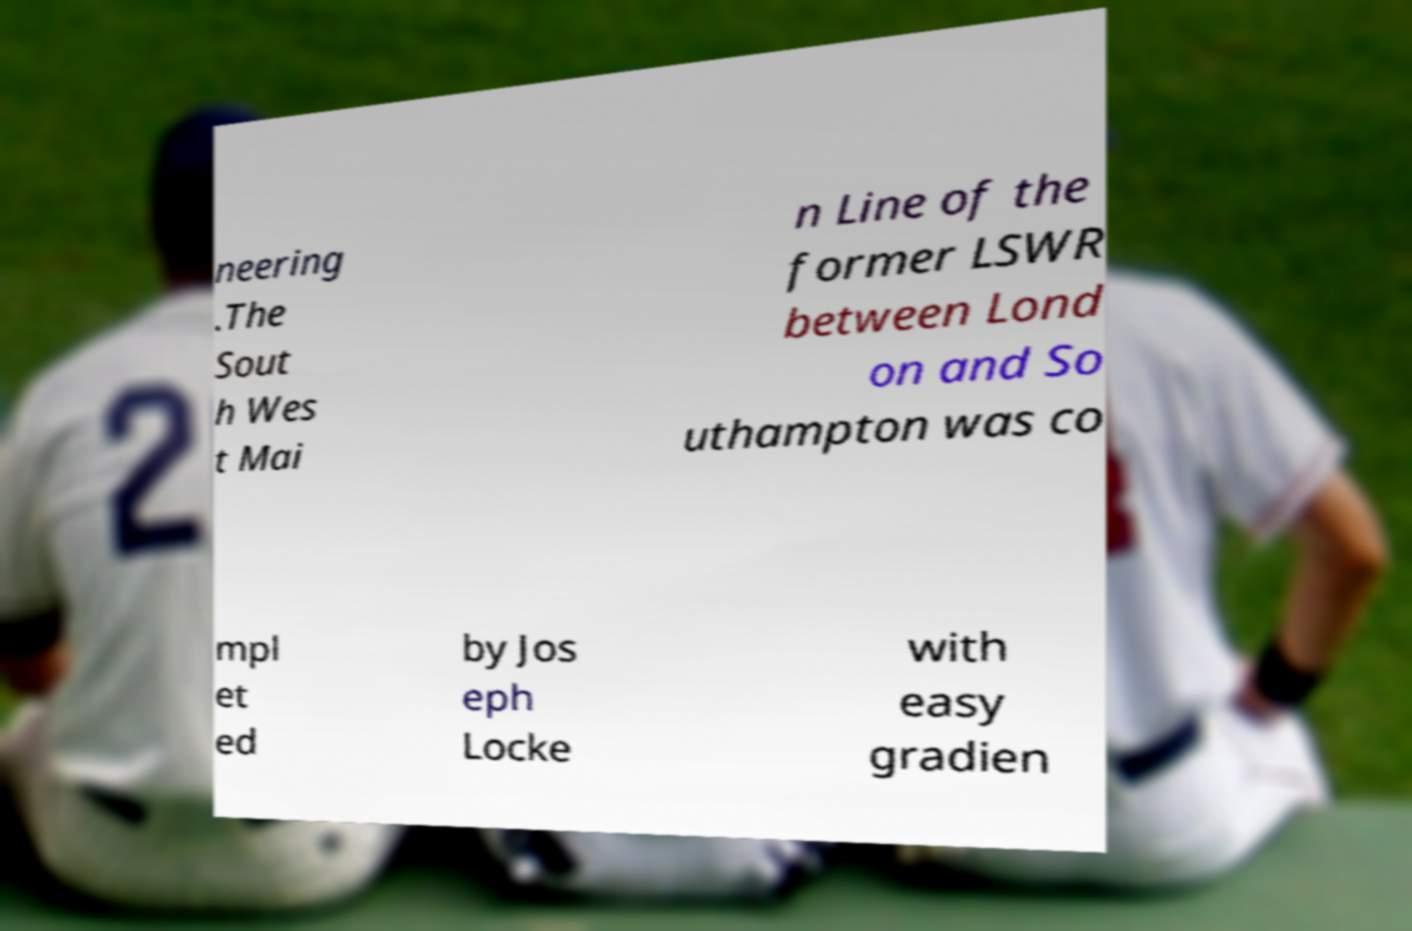Could you extract and type out the text from this image? neering .The Sout h Wes t Mai n Line of the former LSWR between Lond on and So uthampton was co mpl et ed by Jos eph Locke with easy gradien 